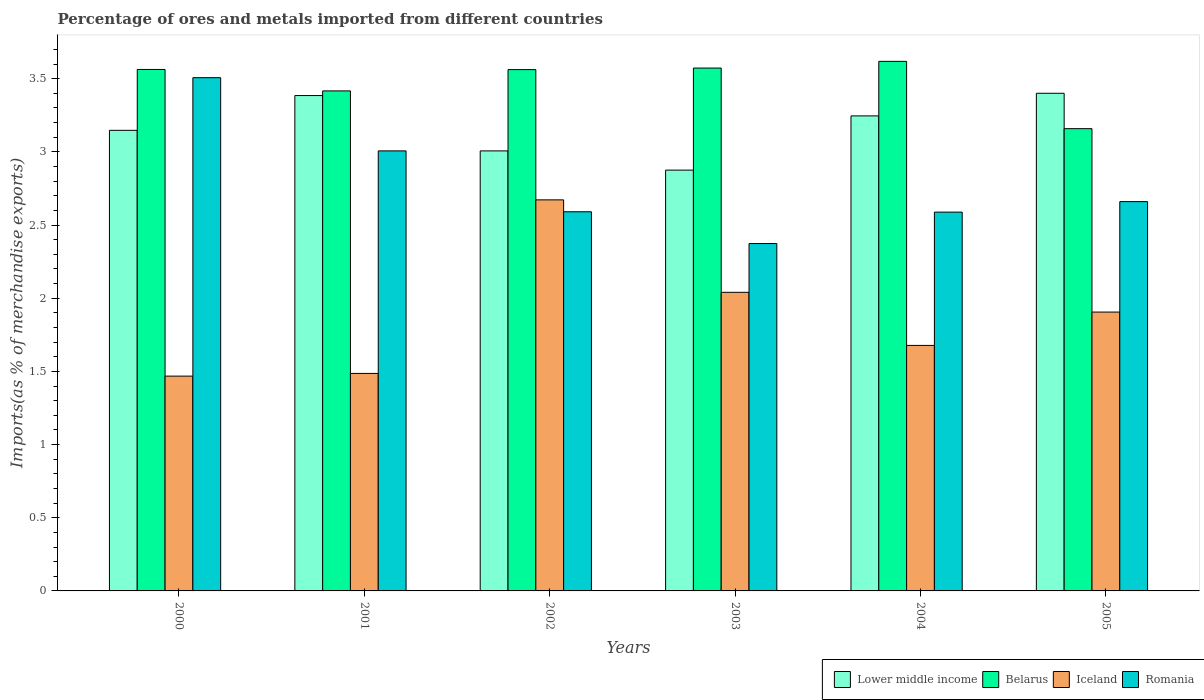How many groups of bars are there?
Provide a succinct answer. 6. What is the label of the 4th group of bars from the left?
Your answer should be compact. 2003. What is the percentage of imports to different countries in Belarus in 2000?
Your response must be concise. 3.56. Across all years, what is the maximum percentage of imports to different countries in Iceland?
Offer a terse response. 2.67. Across all years, what is the minimum percentage of imports to different countries in Romania?
Offer a terse response. 2.37. What is the total percentage of imports to different countries in Lower middle income in the graph?
Make the answer very short. 19.06. What is the difference between the percentage of imports to different countries in Lower middle income in 2000 and that in 2005?
Make the answer very short. -0.25. What is the difference between the percentage of imports to different countries in Belarus in 2005 and the percentage of imports to different countries in Lower middle income in 2002?
Your response must be concise. 0.15. What is the average percentage of imports to different countries in Romania per year?
Your answer should be very brief. 2.79. In the year 2001, what is the difference between the percentage of imports to different countries in Iceland and percentage of imports to different countries in Lower middle income?
Make the answer very short. -1.9. In how many years, is the percentage of imports to different countries in Belarus greater than 1.9 %?
Offer a very short reply. 6. What is the ratio of the percentage of imports to different countries in Iceland in 2003 to that in 2004?
Provide a short and direct response. 1.22. What is the difference between the highest and the second highest percentage of imports to different countries in Romania?
Make the answer very short. 0.5. What is the difference between the highest and the lowest percentage of imports to different countries in Lower middle income?
Provide a short and direct response. 0.53. Is it the case that in every year, the sum of the percentage of imports to different countries in Romania and percentage of imports to different countries in Belarus is greater than the sum of percentage of imports to different countries in Lower middle income and percentage of imports to different countries in Iceland?
Your answer should be compact. No. What does the 4th bar from the left in 2003 represents?
Provide a succinct answer. Romania. What does the 1st bar from the right in 2004 represents?
Your answer should be compact. Romania. How many bars are there?
Provide a succinct answer. 24. What is the difference between two consecutive major ticks on the Y-axis?
Provide a short and direct response. 0.5. Are the values on the major ticks of Y-axis written in scientific E-notation?
Make the answer very short. No. Does the graph contain any zero values?
Keep it short and to the point. No. Where does the legend appear in the graph?
Make the answer very short. Bottom right. How many legend labels are there?
Your answer should be compact. 4. What is the title of the graph?
Provide a succinct answer. Percentage of ores and metals imported from different countries. Does "Greece" appear as one of the legend labels in the graph?
Provide a short and direct response. No. What is the label or title of the X-axis?
Your answer should be very brief. Years. What is the label or title of the Y-axis?
Offer a very short reply. Imports(as % of merchandise exports). What is the Imports(as % of merchandise exports) of Lower middle income in 2000?
Keep it short and to the point. 3.15. What is the Imports(as % of merchandise exports) in Belarus in 2000?
Provide a succinct answer. 3.56. What is the Imports(as % of merchandise exports) of Iceland in 2000?
Provide a succinct answer. 1.47. What is the Imports(as % of merchandise exports) of Romania in 2000?
Give a very brief answer. 3.51. What is the Imports(as % of merchandise exports) in Lower middle income in 2001?
Your answer should be compact. 3.38. What is the Imports(as % of merchandise exports) in Belarus in 2001?
Keep it short and to the point. 3.42. What is the Imports(as % of merchandise exports) in Iceland in 2001?
Your answer should be compact. 1.49. What is the Imports(as % of merchandise exports) of Romania in 2001?
Give a very brief answer. 3.01. What is the Imports(as % of merchandise exports) in Lower middle income in 2002?
Your answer should be very brief. 3.01. What is the Imports(as % of merchandise exports) of Belarus in 2002?
Make the answer very short. 3.56. What is the Imports(as % of merchandise exports) of Iceland in 2002?
Ensure brevity in your answer.  2.67. What is the Imports(as % of merchandise exports) in Romania in 2002?
Make the answer very short. 2.59. What is the Imports(as % of merchandise exports) of Lower middle income in 2003?
Ensure brevity in your answer.  2.88. What is the Imports(as % of merchandise exports) of Belarus in 2003?
Make the answer very short. 3.57. What is the Imports(as % of merchandise exports) of Iceland in 2003?
Offer a very short reply. 2.04. What is the Imports(as % of merchandise exports) of Romania in 2003?
Provide a succinct answer. 2.37. What is the Imports(as % of merchandise exports) of Lower middle income in 2004?
Your answer should be very brief. 3.25. What is the Imports(as % of merchandise exports) of Belarus in 2004?
Offer a very short reply. 3.62. What is the Imports(as % of merchandise exports) in Iceland in 2004?
Your answer should be compact. 1.68. What is the Imports(as % of merchandise exports) in Romania in 2004?
Provide a succinct answer. 2.59. What is the Imports(as % of merchandise exports) in Lower middle income in 2005?
Offer a terse response. 3.4. What is the Imports(as % of merchandise exports) of Belarus in 2005?
Keep it short and to the point. 3.16. What is the Imports(as % of merchandise exports) of Iceland in 2005?
Offer a very short reply. 1.91. What is the Imports(as % of merchandise exports) of Romania in 2005?
Ensure brevity in your answer.  2.66. Across all years, what is the maximum Imports(as % of merchandise exports) of Lower middle income?
Provide a short and direct response. 3.4. Across all years, what is the maximum Imports(as % of merchandise exports) of Belarus?
Provide a succinct answer. 3.62. Across all years, what is the maximum Imports(as % of merchandise exports) in Iceland?
Your answer should be compact. 2.67. Across all years, what is the maximum Imports(as % of merchandise exports) in Romania?
Your answer should be compact. 3.51. Across all years, what is the minimum Imports(as % of merchandise exports) in Lower middle income?
Offer a terse response. 2.88. Across all years, what is the minimum Imports(as % of merchandise exports) of Belarus?
Your answer should be compact. 3.16. Across all years, what is the minimum Imports(as % of merchandise exports) of Iceland?
Give a very brief answer. 1.47. Across all years, what is the minimum Imports(as % of merchandise exports) of Romania?
Make the answer very short. 2.37. What is the total Imports(as % of merchandise exports) in Lower middle income in the graph?
Ensure brevity in your answer.  19.06. What is the total Imports(as % of merchandise exports) in Belarus in the graph?
Your answer should be very brief. 20.89. What is the total Imports(as % of merchandise exports) of Iceland in the graph?
Your response must be concise. 11.25. What is the total Imports(as % of merchandise exports) in Romania in the graph?
Your answer should be compact. 16.73. What is the difference between the Imports(as % of merchandise exports) of Lower middle income in 2000 and that in 2001?
Keep it short and to the point. -0.24. What is the difference between the Imports(as % of merchandise exports) in Belarus in 2000 and that in 2001?
Ensure brevity in your answer.  0.15. What is the difference between the Imports(as % of merchandise exports) in Iceland in 2000 and that in 2001?
Provide a short and direct response. -0.02. What is the difference between the Imports(as % of merchandise exports) in Romania in 2000 and that in 2001?
Give a very brief answer. 0.5. What is the difference between the Imports(as % of merchandise exports) in Lower middle income in 2000 and that in 2002?
Ensure brevity in your answer.  0.14. What is the difference between the Imports(as % of merchandise exports) of Belarus in 2000 and that in 2002?
Your answer should be very brief. 0. What is the difference between the Imports(as % of merchandise exports) in Iceland in 2000 and that in 2002?
Provide a succinct answer. -1.2. What is the difference between the Imports(as % of merchandise exports) in Romania in 2000 and that in 2002?
Keep it short and to the point. 0.92. What is the difference between the Imports(as % of merchandise exports) of Lower middle income in 2000 and that in 2003?
Make the answer very short. 0.27. What is the difference between the Imports(as % of merchandise exports) in Belarus in 2000 and that in 2003?
Your answer should be compact. -0.01. What is the difference between the Imports(as % of merchandise exports) of Iceland in 2000 and that in 2003?
Ensure brevity in your answer.  -0.57. What is the difference between the Imports(as % of merchandise exports) in Romania in 2000 and that in 2003?
Give a very brief answer. 1.13. What is the difference between the Imports(as % of merchandise exports) in Lower middle income in 2000 and that in 2004?
Offer a very short reply. -0.1. What is the difference between the Imports(as % of merchandise exports) in Belarus in 2000 and that in 2004?
Keep it short and to the point. -0.06. What is the difference between the Imports(as % of merchandise exports) in Iceland in 2000 and that in 2004?
Provide a short and direct response. -0.21. What is the difference between the Imports(as % of merchandise exports) in Romania in 2000 and that in 2004?
Your answer should be compact. 0.92. What is the difference between the Imports(as % of merchandise exports) in Lower middle income in 2000 and that in 2005?
Provide a short and direct response. -0.25. What is the difference between the Imports(as % of merchandise exports) of Belarus in 2000 and that in 2005?
Keep it short and to the point. 0.4. What is the difference between the Imports(as % of merchandise exports) of Iceland in 2000 and that in 2005?
Your response must be concise. -0.44. What is the difference between the Imports(as % of merchandise exports) in Romania in 2000 and that in 2005?
Offer a terse response. 0.85. What is the difference between the Imports(as % of merchandise exports) in Lower middle income in 2001 and that in 2002?
Make the answer very short. 0.38. What is the difference between the Imports(as % of merchandise exports) of Belarus in 2001 and that in 2002?
Provide a short and direct response. -0.15. What is the difference between the Imports(as % of merchandise exports) in Iceland in 2001 and that in 2002?
Keep it short and to the point. -1.19. What is the difference between the Imports(as % of merchandise exports) in Romania in 2001 and that in 2002?
Offer a very short reply. 0.42. What is the difference between the Imports(as % of merchandise exports) of Lower middle income in 2001 and that in 2003?
Your response must be concise. 0.51. What is the difference between the Imports(as % of merchandise exports) of Belarus in 2001 and that in 2003?
Your answer should be compact. -0.16. What is the difference between the Imports(as % of merchandise exports) in Iceland in 2001 and that in 2003?
Give a very brief answer. -0.55. What is the difference between the Imports(as % of merchandise exports) of Romania in 2001 and that in 2003?
Your response must be concise. 0.63. What is the difference between the Imports(as % of merchandise exports) in Lower middle income in 2001 and that in 2004?
Offer a terse response. 0.14. What is the difference between the Imports(as % of merchandise exports) in Belarus in 2001 and that in 2004?
Keep it short and to the point. -0.2. What is the difference between the Imports(as % of merchandise exports) of Iceland in 2001 and that in 2004?
Ensure brevity in your answer.  -0.19. What is the difference between the Imports(as % of merchandise exports) in Romania in 2001 and that in 2004?
Your response must be concise. 0.42. What is the difference between the Imports(as % of merchandise exports) of Lower middle income in 2001 and that in 2005?
Your response must be concise. -0.02. What is the difference between the Imports(as % of merchandise exports) in Belarus in 2001 and that in 2005?
Keep it short and to the point. 0.26. What is the difference between the Imports(as % of merchandise exports) of Iceland in 2001 and that in 2005?
Keep it short and to the point. -0.42. What is the difference between the Imports(as % of merchandise exports) of Romania in 2001 and that in 2005?
Keep it short and to the point. 0.35. What is the difference between the Imports(as % of merchandise exports) of Lower middle income in 2002 and that in 2003?
Give a very brief answer. 0.13. What is the difference between the Imports(as % of merchandise exports) in Belarus in 2002 and that in 2003?
Give a very brief answer. -0.01. What is the difference between the Imports(as % of merchandise exports) in Iceland in 2002 and that in 2003?
Your response must be concise. 0.63. What is the difference between the Imports(as % of merchandise exports) in Romania in 2002 and that in 2003?
Provide a succinct answer. 0.22. What is the difference between the Imports(as % of merchandise exports) in Lower middle income in 2002 and that in 2004?
Make the answer very short. -0.24. What is the difference between the Imports(as % of merchandise exports) of Belarus in 2002 and that in 2004?
Make the answer very short. -0.06. What is the difference between the Imports(as % of merchandise exports) of Iceland in 2002 and that in 2004?
Your response must be concise. 0.99. What is the difference between the Imports(as % of merchandise exports) of Romania in 2002 and that in 2004?
Your response must be concise. 0. What is the difference between the Imports(as % of merchandise exports) of Lower middle income in 2002 and that in 2005?
Offer a terse response. -0.39. What is the difference between the Imports(as % of merchandise exports) of Belarus in 2002 and that in 2005?
Provide a short and direct response. 0.4. What is the difference between the Imports(as % of merchandise exports) of Iceland in 2002 and that in 2005?
Provide a succinct answer. 0.77. What is the difference between the Imports(as % of merchandise exports) in Romania in 2002 and that in 2005?
Provide a short and direct response. -0.07. What is the difference between the Imports(as % of merchandise exports) of Lower middle income in 2003 and that in 2004?
Your answer should be compact. -0.37. What is the difference between the Imports(as % of merchandise exports) of Belarus in 2003 and that in 2004?
Give a very brief answer. -0.05. What is the difference between the Imports(as % of merchandise exports) of Iceland in 2003 and that in 2004?
Provide a short and direct response. 0.36. What is the difference between the Imports(as % of merchandise exports) in Romania in 2003 and that in 2004?
Provide a short and direct response. -0.21. What is the difference between the Imports(as % of merchandise exports) of Lower middle income in 2003 and that in 2005?
Your answer should be compact. -0.53. What is the difference between the Imports(as % of merchandise exports) in Belarus in 2003 and that in 2005?
Offer a very short reply. 0.41. What is the difference between the Imports(as % of merchandise exports) of Iceland in 2003 and that in 2005?
Your response must be concise. 0.14. What is the difference between the Imports(as % of merchandise exports) of Romania in 2003 and that in 2005?
Provide a succinct answer. -0.29. What is the difference between the Imports(as % of merchandise exports) in Lower middle income in 2004 and that in 2005?
Your answer should be compact. -0.15. What is the difference between the Imports(as % of merchandise exports) of Belarus in 2004 and that in 2005?
Ensure brevity in your answer.  0.46. What is the difference between the Imports(as % of merchandise exports) in Iceland in 2004 and that in 2005?
Ensure brevity in your answer.  -0.23. What is the difference between the Imports(as % of merchandise exports) in Romania in 2004 and that in 2005?
Provide a succinct answer. -0.07. What is the difference between the Imports(as % of merchandise exports) of Lower middle income in 2000 and the Imports(as % of merchandise exports) of Belarus in 2001?
Offer a terse response. -0.27. What is the difference between the Imports(as % of merchandise exports) in Lower middle income in 2000 and the Imports(as % of merchandise exports) in Iceland in 2001?
Make the answer very short. 1.66. What is the difference between the Imports(as % of merchandise exports) in Lower middle income in 2000 and the Imports(as % of merchandise exports) in Romania in 2001?
Provide a short and direct response. 0.14. What is the difference between the Imports(as % of merchandise exports) of Belarus in 2000 and the Imports(as % of merchandise exports) of Iceland in 2001?
Provide a short and direct response. 2.08. What is the difference between the Imports(as % of merchandise exports) of Belarus in 2000 and the Imports(as % of merchandise exports) of Romania in 2001?
Provide a short and direct response. 0.56. What is the difference between the Imports(as % of merchandise exports) in Iceland in 2000 and the Imports(as % of merchandise exports) in Romania in 2001?
Offer a terse response. -1.54. What is the difference between the Imports(as % of merchandise exports) in Lower middle income in 2000 and the Imports(as % of merchandise exports) in Belarus in 2002?
Offer a terse response. -0.41. What is the difference between the Imports(as % of merchandise exports) of Lower middle income in 2000 and the Imports(as % of merchandise exports) of Iceland in 2002?
Ensure brevity in your answer.  0.48. What is the difference between the Imports(as % of merchandise exports) in Lower middle income in 2000 and the Imports(as % of merchandise exports) in Romania in 2002?
Offer a very short reply. 0.56. What is the difference between the Imports(as % of merchandise exports) of Belarus in 2000 and the Imports(as % of merchandise exports) of Iceland in 2002?
Keep it short and to the point. 0.89. What is the difference between the Imports(as % of merchandise exports) in Belarus in 2000 and the Imports(as % of merchandise exports) in Romania in 2002?
Your answer should be compact. 0.97. What is the difference between the Imports(as % of merchandise exports) of Iceland in 2000 and the Imports(as % of merchandise exports) of Romania in 2002?
Offer a terse response. -1.12. What is the difference between the Imports(as % of merchandise exports) of Lower middle income in 2000 and the Imports(as % of merchandise exports) of Belarus in 2003?
Ensure brevity in your answer.  -0.43. What is the difference between the Imports(as % of merchandise exports) in Lower middle income in 2000 and the Imports(as % of merchandise exports) in Iceland in 2003?
Ensure brevity in your answer.  1.11. What is the difference between the Imports(as % of merchandise exports) of Lower middle income in 2000 and the Imports(as % of merchandise exports) of Romania in 2003?
Keep it short and to the point. 0.77. What is the difference between the Imports(as % of merchandise exports) in Belarus in 2000 and the Imports(as % of merchandise exports) in Iceland in 2003?
Ensure brevity in your answer.  1.52. What is the difference between the Imports(as % of merchandise exports) in Belarus in 2000 and the Imports(as % of merchandise exports) in Romania in 2003?
Offer a very short reply. 1.19. What is the difference between the Imports(as % of merchandise exports) of Iceland in 2000 and the Imports(as % of merchandise exports) of Romania in 2003?
Your answer should be compact. -0.91. What is the difference between the Imports(as % of merchandise exports) of Lower middle income in 2000 and the Imports(as % of merchandise exports) of Belarus in 2004?
Offer a terse response. -0.47. What is the difference between the Imports(as % of merchandise exports) of Lower middle income in 2000 and the Imports(as % of merchandise exports) of Iceland in 2004?
Make the answer very short. 1.47. What is the difference between the Imports(as % of merchandise exports) of Lower middle income in 2000 and the Imports(as % of merchandise exports) of Romania in 2004?
Keep it short and to the point. 0.56. What is the difference between the Imports(as % of merchandise exports) of Belarus in 2000 and the Imports(as % of merchandise exports) of Iceland in 2004?
Your answer should be compact. 1.89. What is the difference between the Imports(as % of merchandise exports) in Belarus in 2000 and the Imports(as % of merchandise exports) in Romania in 2004?
Ensure brevity in your answer.  0.97. What is the difference between the Imports(as % of merchandise exports) of Iceland in 2000 and the Imports(as % of merchandise exports) of Romania in 2004?
Ensure brevity in your answer.  -1.12. What is the difference between the Imports(as % of merchandise exports) in Lower middle income in 2000 and the Imports(as % of merchandise exports) in Belarus in 2005?
Make the answer very short. -0.01. What is the difference between the Imports(as % of merchandise exports) of Lower middle income in 2000 and the Imports(as % of merchandise exports) of Iceland in 2005?
Offer a very short reply. 1.24. What is the difference between the Imports(as % of merchandise exports) of Lower middle income in 2000 and the Imports(as % of merchandise exports) of Romania in 2005?
Ensure brevity in your answer.  0.49. What is the difference between the Imports(as % of merchandise exports) of Belarus in 2000 and the Imports(as % of merchandise exports) of Iceland in 2005?
Ensure brevity in your answer.  1.66. What is the difference between the Imports(as % of merchandise exports) in Belarus in 2000 and the Imports(as % of merchandise exports) in Romania in 2005?
Your response must be concise. 0.9. What is the difference between the Imports(as % of merchandise exports) in Iceland in 2000 and the Imports(as % of merchandise exports) in Romania in 2005?
Your answer should be compact. -1.19. What is the difference between the Imports(as % of merchandise exports) of Lower middle income in 2001 and the Imports(as % of merchandise exports) of Belarus in 2002?
Provide a succinct answer. -0.18. What is the difference between the Imports(as % of merchandise exports) of Lower middle income in 2001 and the Imports(as % of merchandise exports) of Iceland in 2002?
Ensure brevity in your answer.  0.71. What is the difference between the Imports(as % of merchandise exports) of Lower middle income in 2001 and the Imports(as % of merchandise exports) of Romania in 2002?
Give a very brief answer. 0.79. What is the difference between the Imports(as % of merchandise exports) in Belarus in 2001 and the Imports(as % of merchandise exports) in Iceland in 2002?
Provide a short and direct response. 0.74. What is the difference between the Imports(as % of merchandise exports) of Belarus in 2001 and the Imports(as % of merchandise exports) of Romania in 2002?
Offer a very short reply. 0.83. What is the difference between the Imports(as % of merchandise exports) of Iceland in 2001 and the Imports(as % of merchandise exports) of Romania in 2002?
Provide a short and direct response. -1.1. What is the difference between the Imports(as % of merchandise exports) in Lower middle income in 2001 and the Imports(as % of merchandise exports) in Belarus in 2003?
Provide a succinct answer. -0.19. What is the difference between the Imports(as % of merchandise exports) of Lower middle income in 2001 and the Imports(as % of merchandise exports) of Iceland in 2003?
Offer a terse response. 1.34. What is the difference between the Imports(as % of merchandise exports) in Lower middle income in 2001 and the Imports(as % of merchandise exports) in Romania in 2003?
Make the answer very short. 1.01. What is the difference between the Imports(as % of merchandise exports) of Belarus in 2001 and the Imports(as % of merchandise exports) of Iceland in 2003?
Keep it short and to the point. 1.38. What is the difference between the Imports(as % of merchandise exports) of Belarus in 2001 and the Imports(as % of merchandise exports) of Romania in 2003?
Provide a succinct answer. 1.04. What is the difference between the Imports(as % of merchandise exports) in Iceland in 2001 and the Imports(as % of merchandise exports) in Romania in 2003?
Provide a succinct answer. -0.89. What is the difference between the Imports(as % of merchandise exports) in Lower middle income in 2001 and the Imports(as % of merchandise exports) in Belarus in 2004?
Keep it short and to the point. -0.23. What is the difference between the Imports(as % of merchandise exports) of Lower middle income in 2001 and the Imports(as % of merchandise exports) of Iceland in 2004?
Provide a succinct answer. 1.71. What is the difference between the Imports(as % of merchandise exports) of Lower middle income in 2001 and the Imports(as % of merchandise exports) of Romania in 2004?
Ensure brevity in your answer.  0.8. What is the difference between the Imports(as % of merchandise exports) of Belarus in 2001 and the Imports(as % of merchandise exports) of Iceland in 2004?
Offer a terse response. 1.74. What is the difference between the Imports(as % of merchandise exports) in Belarus in 2001 and the Imports(as % of merchandise exports) in Romania in 2004?
Provide a short and direct response. 0.83. What is the difference between the Imports(as % of merchandise exports) of Iceland in 2001 and the Imports(as % of merchandise exports) of Romania in 2004?
Your answer should be compact. -1.1. What is the difference between the Imports(as % of merchandise exports) in Lower middle income in 2001 and the Imports(as % of merchandise exports) in Belarus in 2005?
Provide a short and direct response. 0.23. What is the difference between the Imports(as % of merchandise exports) of Lower middle income in 2001 and the Imports(as % of merchandise exports) of Iceland in 2005?
Provide a succinct answer. 1.48. What is the difference between the Imports(as % of merchandise exports) of Lower middle income in 2001 and the Imports(as % of merchandise exports) of Romania in 2005?
Provide a succinct answer. 0.72. What is the difference between the Imports(as % of merchandise exports) in Belarus in 2001 and the Imports(as % of merchandise exports) in Iceland in 2005?
Your response must be concise. 1.51. What is the difference between the Imports(as % of merchandise exports) of Belarus in 2001 and the Imports(as % of merchandise exports) of Romania in 2005?
Make the answer very short. 0.76. What is the difference between the Imports(as % of merchandise exports) of Iceland in 2001 and the Imports(as % of merchandise exports) of Romania in 2005?
Give a very brief answer. -1.17. What is the difference between the Imports(as % of merchandise exports) of Lower middle income in 2002 and the Imports(as % of merchandise exports) of Belarus in 2003?
Your answer should be compact. -0.57. What is the difference between the Imports(as % of merchandise exports) of Lower middle income in 2002 and the Imports(as % of merchandise exports) of Iceland in 2003?
Offer a terse response. 0.97. What is the difference between the Imports(as % of merchandise exports) of Lower middle income in 2002 and the Imports(as % of merchandise exports) of Romania in 2003?
Your answer should be very brief. 0.63. What is the difference between the Imports(as % of merchandise exports) of Belarus in 2002 and the Imports(as % of merchandise exports) of Iceland in 2003?
Make the answer very short. 1.52. What is the difference between the Imports(as % of merchandise exports) of Belarus in 2002 and the Imports(as % of merchandise exports) of Romania in 2003?
Give a very brief answer. 1.19. What is the difference between the Imports(as % of merchandise exports) in Iceland in 2002 and the Imports(as % of merchandise exports) in Romania in 2003?
Offer a terse response. 0.3. What is the difference between the Imports(as % of merchandise exports) in Lower middle income in 2002 and the Imports(as % of merchandise exports) in Belarus in 2004?
Make the answer very short. -0.61. What is the difference between the Imports(as % of merchandise exports) of Lower middle income in 2002 and the Imports(as % of merchandise exports) of Iceland in 2004?
Your answer should be compact. 1.33. What is the difference between the Imports(as % of merchandise exports) of Lower middle income in 2002 and the Imports(as % of merchandise exports) of Romania in 2004?
Provide a succinct answer. 0.42. What is the difference between the Imports(as % of merchandise exports) of Belarus in 2002 and the Imports(as % of merchandise exports) of Iceland in 2004?
Give a very brief answer. 1.88. What is the difference between the Imports(as % of merchandise exports) of Belarus in 2002 and the Imports(as % of merchandise exports) of Romania in 2004?
Your answer should be very brief. 0.97. What is the difference between the Imports(as % of merchandise exports) in Iceland in 2002 and the Imports(as % of merchandise exports) in Romania in 2004?
Your answer should be compact. 0.08. What is the difference between the Imports(as % of merchandise exports) in Lower middle income in 2002 and the Imports(as % of merchandise exports) in Belarus in 2005?
Keep it short and to the point. -0.15. What is the difference between the Imports(as % of merchandise exports) of Lower middle income in 2002 and the Imports(as % of merchandise exports) of Iceland in 2005?
Your answer should be compact. 1.1. What is the difference between the Imports(as % of merchandise exports) of Lower middle income in 2002 and the Imports(as % of merchandise exports) of Romania in 2005?
Offer a terse response. 0.35. What is the difference between the Imports(as % of merchandise exports) in Belarus in 2002 and the Imports(as % of merchandise exports) in Iceland in 2005?
Provide a succinct answer. 1.66. What is the difference between the Imports(as % of merchandise exports) of Belarus in 2002 and the Imports(as % of merchandise exports) of Romania in 2005?
Make the answer very short. 0.9. What is the difference between the Imports(as % of merchandise exports) of Iceland in 2002 and the Imports(as % of merchandise exports) of Romania in 2005?
Your answer should be very brief. 0.01. What is the difference between the Imports(as % of merchandise exports) in Lower middle income in 2003 and the Imports(as % of merchandise exports) in Belarus in 2004?
Your response must be concise. -0.74. What is the difference between the Imports(as % of merchandise exports) in Lower middle income in 2003 and the Imports(as % of merchandise exports) in Iceland in 2004?
Give a very brief answer. 1.2. What is the difference between the Imports(as % of merchandise exports) of Lower middle income in 2003 and the Imports(as % of merchandise exports) of Romania in 2004?
Your answer should be compact. 0.29. What is the difference between the Imports(as % of merchandise exports) in Belarus in 2003 and the Imports(as % of merchandise exports) in Iceland in 2004?
Provide a succinct answer. 1.9. What is the difference between the Imports(as % of merchandise exports) in Belarus in 2003 and the Imports(as % of merchandise exports) in Romania in 2004?
Give a very brief answer. 0.98. What is the difference between the Imports(as % of merchandise exports) of Iceland in 2003 and the Imports(as % of merchandise exports) of Romania in 2004?
Give a very brief answer. -0.55. What is the difference between the Imports(as % of merchandise exports) in Lower middle income in 2003 and the Imports(as % of merchandise exports) in Belarus in 2005?
Your answer should be very brief. -0.28. What is the difference between the Imports(as % of merchandise exports) of Lower middle income in 2003 and the Imports(as % of merchandise exports) of Iceland in 2005?
Provide a short and direct response. 0.97. What is the difference between the Imports(as % of merchandise exports) of Lower middle income in 2003 and the Imports(as % of merchandise exports) of Romania in 2005?
Make the answer very short. 0.22. What is the difference between the Imports(as % of merchandise exports) of Belarus in 2003 and the Imports(as % of merchandise exports) of Iceland in 2005?
Your response must be concise. 1.67. What is the difference between the Imports(as % of merchandise exports) in Belarus in 2003 and the Imports(as % of merchandise exports) in Romania in 2005?
Your answer should be compact. 0.91. What is the difference between the Imports(as % of merchandise exports) of Iceland in 2003 and the Imports(as % of merchandise exports) of Romania in 2005?
Offer a very short reply. -0.62. What is the difference between the Imports(as % of merchandise exports) of Lower middle income in 2004 and the Imports(as % of merchandise exports) of Belarus in 2005?
Provide a short and direct response. 0.09. What is the difference between the Imports(as % of merchandise exports) of Lower middle income in 2004 and the Imports(as % of merchandise exports) of Iceland in 2005?
Your response must be concise. 1.34. What is the difference between the Imports(as % of merchandise exports) in Lower middle income in 2004 and the Imports(as % of merchandise exports) in Romania in 2005?
Ensure brevity in your answer.  0.59. What is the difference between the Imports(as % of merchandise exports) in Belarus in 2004 and the Imports(as % of merchandise exports) in Iceland in 2005?
Ensure brevity in your answer.  1.71. What is the difference between the Imports(as % of merchandise exports) in Belarus in 2004 and the Imports(as % of merchandise exports) in Romania in 2005?
Offer a terse response. 0.96. What is the difference between the Imports(as % of merchandise exports) in Iceland in 2004 and the Imports(as % of merchandise exports) in Romania in 2005?
Provide a short and direct response. -0.98. What is the average Imports(as % of merchandise exports) in Lower middle income per year?
Your response must be concise. 3.18. What is the average Imports(as % of merchandise exports) of Belarus per year?
Your response must be concise. 3.48. What is the average Imports(as % of merchandise exports) in Iceland per year?
Your answer should be very brief. 1.87. What is the average Imports(as % of merchandise exports) of Romania per year?
Provide a succinct answer. 2.79. In the year 2000, what is the difference between the Imports(as % of merchandise exports) of Lower middle income and Imports(as % of merchandise exports) of Belarus?
Provide a short and direct response. -0.42. In the year 2000, what is the difference between the Imports(as % of merchandise exports) in Lower middle income and Imports(as % of merchandise exports) in Iceland?
Your answer should be very brief. 1.68. In the year 2000, what is the difference between the Imports(as % of merchandise exports) in Lower middle income and Imports(as % of merchandise exports) in Romania?
Offer a very short reply. -0.36. In the year 2000, what is the difference between the Imports(as % of merchandise exports) in Belarus and Imports(as % of merchandise exports) in Iceland?
Your answer should be very brief. 2.1. In the year 2000, what is the difference between the Imports(as % of merchandise exports) of Belarus and Imports(as % of merchandise exports) of Romania?
Give a very brief answer. 0.06. In the year 2000, what is the difference between the Imports(as % of merchandise exports) in Iceland and Imports(as % of merchandise exports) in Romania?
Provide a short and direct response. -2.04. In the year 2001, what is the difference between the Imports(as % of merchandise exports) of Lower middle income and Imports(as % of merchandise exports) of Belarus?
Provide a succinct answer. -0.03. In the year 2001, what is the difference between the Imports(as % of merchandise exports) of Lower middle income and Imports(as % of merchandise exports) of Iceland?
Make the answer very short. 1.9. In the year 2001, what is the difference between the Imports(as % of merchandise exports) of Lower middle income and Imports(as % of merchandise exports) of Romania?
Make the answer very short. 0.38. In the year 2001, what is the difference between the Imports(as % of merchandise exports) of Belarus and Imports(as % of merchandise exports) of Iceland?
Your answer should be very brief. 1.93. In the year 2001, what is the difference between the Imports(as % of merchandise exports) of Belarus and Imports(as % of merchandise exports) of Romania?
Your response must be concise. 0.41. In the year 2001, what is the difference between the Imports(as % of merchandise exports) in Iceland and Imports(as % of merchandise exports) in Romania?
Provide a succinct answer. -1.52. In the year 2002, what is the difference between the Imports(as % of merchandise exports) of Lower middle income and Imports(as % of merchandise exports) of Belarus?
Give a very brief answer. -0.56. In the year 2002, what is the difference between the Imports(as % of merchandise exports) in Lower middle income and Imports(as % of merchandise exports) in Iceland?
Keep it short and to the point. 0.33. In the year 2002, what is the difference between the Imports(as % of merchandise exports) of Lower middle income and Imports(as % of merchandise exports) of Romania?
Ensure brevity in your answer.  0.42. In the year 2002, what is the difference between the Imports(as % of merchandise exports) of Belarus and Imports(as % of merchandise exports) of Iceland?
Offer a terse response. 0.89. In the year 2002, what is the difference between the Imports(as % of merchandise exports) of Belarus and Imports(as % of merchandise exports) of Romania?
Your response must be concise. 0.97. In the year 2002, what is the difference between the Imports(as % of merchandise exports) in Iceland and Imports(as % of merchandise exports) in Romania?
Your answer should be compact. 0.08. In the year 2003, what is the difference between the Imports(as % of merchandise exports) of Lower middle income and Imports(as % of merchandise exports) of Belarus?
Provide a short and direct response. -0.7. In the year 2003, what is the difference between the Imports(as % of merchandise exports) of Lower middle income and Imports(as % of merchandise exports) of Iceland?
Your response must be concise. 0.83. In the year 2003, what is the difference between the Imports(as % of merchandise exports) in Lower middle income and Imports(as % of merchandise exports) in Romania?
Offer a terse response. 0.5. In the year 2003, what is the difference between the Imports(as % of merchandise exports) in Belarus and Imports(as % of merchandise exports) in Iceland?
Your answer should be very brief. 1.53. In the year 2003, what is the difference between the Imports(as % of merchandise exports) in Belarus and Imports(as % of merchandise exports) in Romania?
Keep it short and to the point. 1.2. In the year 2003, what is the difference between the Imports(as % of merchandise exports) of Iceland and Imports(as % of merchandise exports) of Romania?
Ensure brevity in your answer.  -0.33. In the year 2004, what is the difference between the Imports(as % of merchandise exports) in Lower middle income and Imports(as % of merchandise exports) in Belarus?
Make the answer very short. -0.37. In the year 2004, what is the difference between the Imports(as % of merchandise exports) of Lower middle income and Imports(as % of merchandise exports) of Iceland?
Your answer should be compact. 1.57. In the year 2004, what is the difference between the Imports(as % of merchandise exports) in Lower middle income and Imports(as % of merchandise exports) in Romania?
Make the answer very short. 0.66. In the year 2004, what is the difference between the Imports(as % of merchandise exports) of Belarus and Imports(as % of merchandise exports) of Iceland?
Ensure brevity in your answer.  1.94. In the year 2004, what is the difference between the Imports(as % of merchandise exports) in Belarus and Imports(as % of merchandise exports) in Romania?
Ensure brevity in your answer.  1.03. In the year 2004, what is the difference between the Imports(as % of merchandise exports) of Iceland and Imports(as % of merchandise exports) of Romania?
Offer a very short reply. -0.91. In the year 2005, what is the difference between the Imports(as % of merchandise exports) of Lower middle income and Imports(as % of merchandise exports) of Belarus?
Ensure brevity in your answer.  0.24. In the year 2005, what is the difference between the Imports(as % of merchandise exports) of Lower middle income and Imports(as % of merchandise exports) of Iceland?
Keep it short and to the point. 1.5. In the year 2005, what is the difference between the Imports(as % of merchandise exports) of Lower middle income and Imports(as % of merchandise exports) of Romania?
Provide a short and direct response. 0.74. In the year 2005, what is the difference between the Imports(as % of merchandise exports) of Belarus and Imports(as % of merchandise exports) of Iceland?
Provide a short and direct response. 1.25. In the year 2005, what is the difference between the Imports(as % of merchandise exports) of Belarus and Imports(as % of merchandise exports) of Romania?
Your answer should be compact. 0.5. In the year 2005, what is the difference between the Imports(as % of merchandise exports) in Iceland and Imports(as % of merchandise exports) in Romania?
Your answer should be compact. -0.75. What is the ratio of the Imports(as % of merchandise exports) in Lower middle income in 2000 to that in 2001?
Provide a succinct answer. 0.93. What is the ratio of the Imports(as % of merchandise exports) in Belarus in 2000 to that in 2001?
Keep it short and to the point. 1.04. What is the ratio of the Imports(as % of merchandise exports) of Iceland in 2000 to that in 2001?
Your response must be concise. 0.99. What is the ratio of the Imports(as % of merchandise exports) of Romania in 2000 to that in 2001?
Provide a succinct answer. 1.17. What is the ratio of the Imports(as % of merchandise exports) of Lower middle income in 2000 to that in 2002?
Provide a succinct answer. 1.05. What is the ratio of the Imports(as % of merchandise exports) of Belarus in 2000 to that in 2002?
Your response must be concise. 1. What is the ratio of the Imports(as % of merchandise exports) of Iceland in 2000 to that in 2002?
Offer a terse response. 0.55. What is the ratio of the Imports(as % of merchandise exports) in Romania in 2000 to that in 2002?
Ensure brevity in your answer.  1.35. What is the ratio of the Imports(as % of merchandise exports) in Lower middle income in 2000 to that in 2003?
Your answer should be very brief. 1.09. What is the ratio of the Imports(as % of merchandise exports) of Iceland in 2000 to that in 2003?
Offer a very short reply. 0.72. What is the ratio of the Imports(as % of merchandise exports) in Romania in 2000 to that in 2003?
Keep it short and to the point. 1.48. What is the ratio of the Imports(as % of merchandise exports) of Lower middle income in 2000 to that in 2004?
Your answer should be very brief. 0.97. What is the ratio of the Imports(as % of merchandise exports) of Belarus in 2000 to that in 2004?
Give a very brief answer. 0.98. What is the ratio of the Imports(as % of merchandise exports) of Iceland in 2000 to that in 2004?
Offer a very short reply. 0.87. What is the ratio of the Imports(as % of merchandise exports) of Romania in 2000 to that in 2004?
Give a very brief answer. 1.35. What is the ratio of the Imports(as % of merchandise exports) in Lower middle income in 2000 to that in 2005?
Your response must be concise. 0.93. What is the ratio of the Imports(as % of merchandise exports) of Belarus in 2000 to that in 2005?
Your answer should be very brief. 1.13. What is the ratio of the Imports(as % of merchandise exports) in Iceland in 2000 to that in 2005?
Keep it short and to the point. 0.77. What is the ratio of the Imports(as % of merchandise exports) in Romania in 2000 to that in 2005?
Ensure brevity in your answer.  1.32. What is the ratio of the Imports(as % of merchandise exports) in Lower middle income in 2001 to that in 2002?
Keep it short and to the point. 1.13. What is the ratio of the Imports(as % of merchandise exports) in Belarus in 2001 to that in 2002?
Provide a succinct answer. 0.96. What is the ratio of the Imports(as % of merchandise exports) in Iceland in 2001 to that in 2002?
Offer a terse response. 0.56. What is the ratio of the Imports(as % of merchandise exports) of Romania in 2001 to that in 2002?
Offer a terse response. 1.16. What is the ratio of the Imports(as % of merchandise exports) in Lower middle income in 2001 to that in 2003?
Offer a very short reply. 1.18. What is the ratio of the Imports(as % of merchandise exports) in Belarus in 2001 to that in 2003?
Your answer should be very brief. 0.96. What is the ratio of the Imports(as % of merchandise exports) in Iceland in 2001 to that in 2003?
Offer a terse response. 0.73. What is the ratio of the Imports(as % of merchandise exports) of Romania in 2001 to that in 2003?
Keep it short and to the point. 1.27. What is the ratio of the Imports(as % of merchandise exports) in Lower middle income in 2001 to that in 2004?
Offer a very short reply. 1.04. What is the ratio of the Imports(as % of merchandise exports) of Belarus in 2001 to that in 2004?
Your response must be concise. 0.94. What is the ratio of the Imports(as % of merchandise exports) in Iceland in 2001 to that in 2004?
Your response must be concise. 0.89. What is the ratio of the Imports(as % of merchandise exports) of Romania in 2001 to that in 2004?
Keep it short and to the point. 1.16. What is the ratio of the Imports(as % of merchandise exports) in Lower middle income in 2001 to that in 2005?
Your response must be concise. 1. What is the ratio of the Imports(as % of merchandise exports) of Belarus in 2001 to that in 2005?
Give a very brief answer. 1.08. What is the ratio of the Imports(as % of merchandise exports) of Iceland in 2001 to that in 2005?
Offer a very short reply. 0.78. What is the ratio of the Imports(as % of merchandise exports) of Romania in 2001 to that in 2005?
Your answer should be compact. 1.13. What is the ratio of the Imports(as % of merchandise exports) in Lower middle income in 2002 to that in 2003?
Offer a terse response. 1.05. What is the ratio of the Imports(as % of merchandise exports) of Iceland in 2002 to that in 2003?
Your response must be concise. 1.31. What is the ratio of the Imports(as % of merchandise exports) of Romania in 2002 to that in 2003?
Offer a terse response. 1.09. What is the ratio of the Imports(as % of merchandise exports) of Lower middle income in 2002 to that in 2004?
Your response must be concise. 0.93. What is the ratio of the Imports(as % of merchandise exports) in Belarus in 2002 to that in 2004?
Give a very brief answer. 0.98. What is the ratio of the Imports(as % of merchandise exports) of Iceland in 2002 to that in 2004?
Your answer should be very brief. 1.59. What is the ratio of the Imports(as % of merchandise exports) in Lower middle income in 2002 to that in 2005?
Your response must be concise. 0.88. What is the ratio of the Imports(as % of merchandise exports) in Belarus in 2002 to that in 2005?
Your answer should be compact. 1.13. What is the ratio of the Imports(as % of merchandise exports) of Iceland in 2002 to that in 2005?
Your answer should be very brief. 1.4. What is the ratio of the Imports(as % of merchandise exports) in Romania in 2002 to that in 2005?
Provide a succinct answer. 0.97. What is the ratio of the Imports(as % of merchandise exports) in Lower middle income in 2003 to that in 2004?
Offer a terse response. 0.89. What is the ratio of the Imports(as % of merchandise exports) of Belarus in 2003 to that in 2004?
Your answer should be compact. 0.99. What is the ratio of the Imports(as % of merchandise exports) in Iceland in 2003 to that in 2004?
Give a very brief answer. 1.22. What is the ratio of the Imports(as % of merchandise exports) of Romania in 2003 to that in 2004?
Your response must be concise. 0.92. What is the ratio of the Imports(as % of merchandise exports) of Lower middle income in 2003 to that in 2005?
Give a very brief answer. 0.85. What is the ratio of the Imports(as % of merchandise exports) of Belarus in 2003 to that in 2005?
Make the answer very short. 1.13. What is the ratio of the Imports(as % of merchandise exports) in Iceland in 2003 to that in 2005?
Your response must be concise. 1.07. What is the ratio of the Imports(as % of merchandise exports) of Romania in 2003 to that in 2005?
Offer a very short reply. 0.89. What is the ratio of the Imports(as % of merchandise exports) of Lower middle income in 2004 to that in 2005?
Provide a succinct answer. 0.95. What is the ratio of the Imports(as % of merchandise exports) of Belarus in 2004 to that in 2005?
Offer a terse response. 1.15. What is the ratio of the Imports(as % of merchandise exports) of Iceland in 2004 to that in 2005?
Ensure brevity in your answer.  0.88. What is the ratio of the Imports(as % of merchandise exports) in Romania in 2004 to that in 2005?
Provide a short and direct response. 0.97. What is the difference between the highest and the second highest Imports(as % of merchandise exports) in Lower middle income?
Give a very brief answer. 0.02. What is the difference between the highest and the second highest Imports(as % of merchandise exports) in Belarus?
Your answer should be very brief. 0.05. What is the difference between the highest and the second highest Imports(as % of merchandise exports) of Iceland?
Your response must be concise. 0.63. What is the difference between the highest and the second highest Imports(as % of merchandise exports) of Romania?
Keep it short and to the point. 0.5. What is the difference between the highest and the lowest Imports(as % of merchandise exports) of Lower middle income?
Provide a short and direct response. 0.53. What is the difference between the highest and the lowest Imports(as % of merchandise exports) in Belarus?
Your answer should be compact. 0.46. What is the difference between the highest and the lowest Imports(as % of merchandise exports) of Iceland?
Your answer should be very brief. 1.2. What is the difference between the highest and the lowest Imports(as % of merchandise exports) of Romania?
Ensure brevity in your answer.  1.13. 